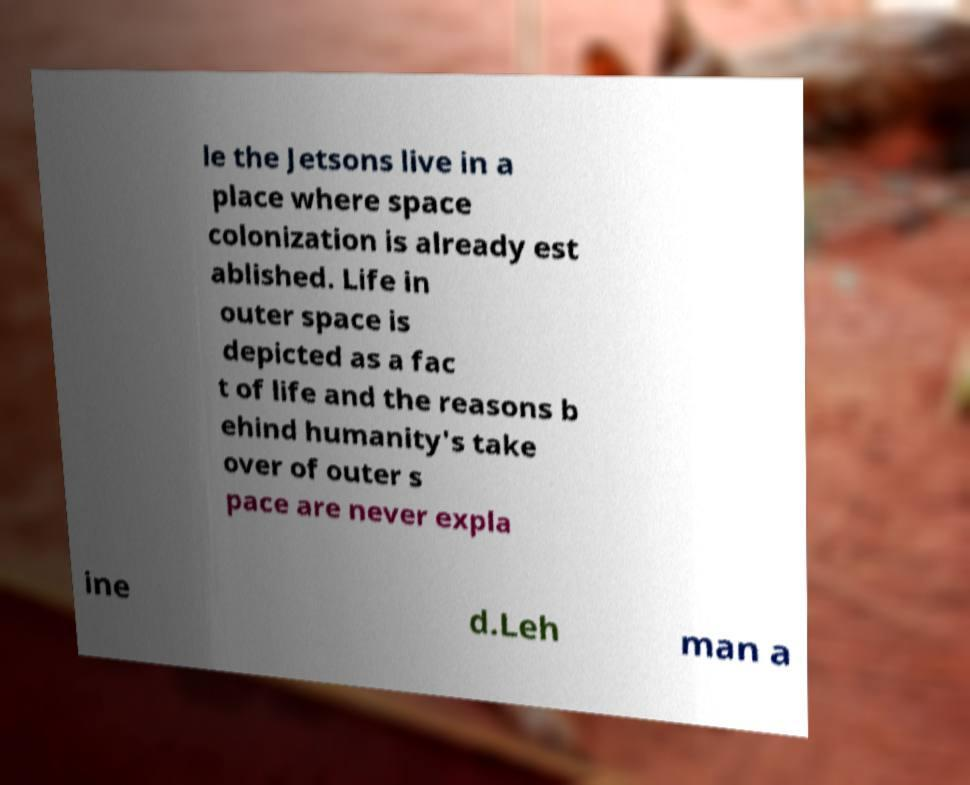Please read and relay the text visible in this image. What does it say? le the Jetsons live in a place where space colonization is already est ablished. Life in outer space is depicted as a fac t of life and the reasons b ehind humanity's take over of outer s pace are never expla ine d.Leh man a 